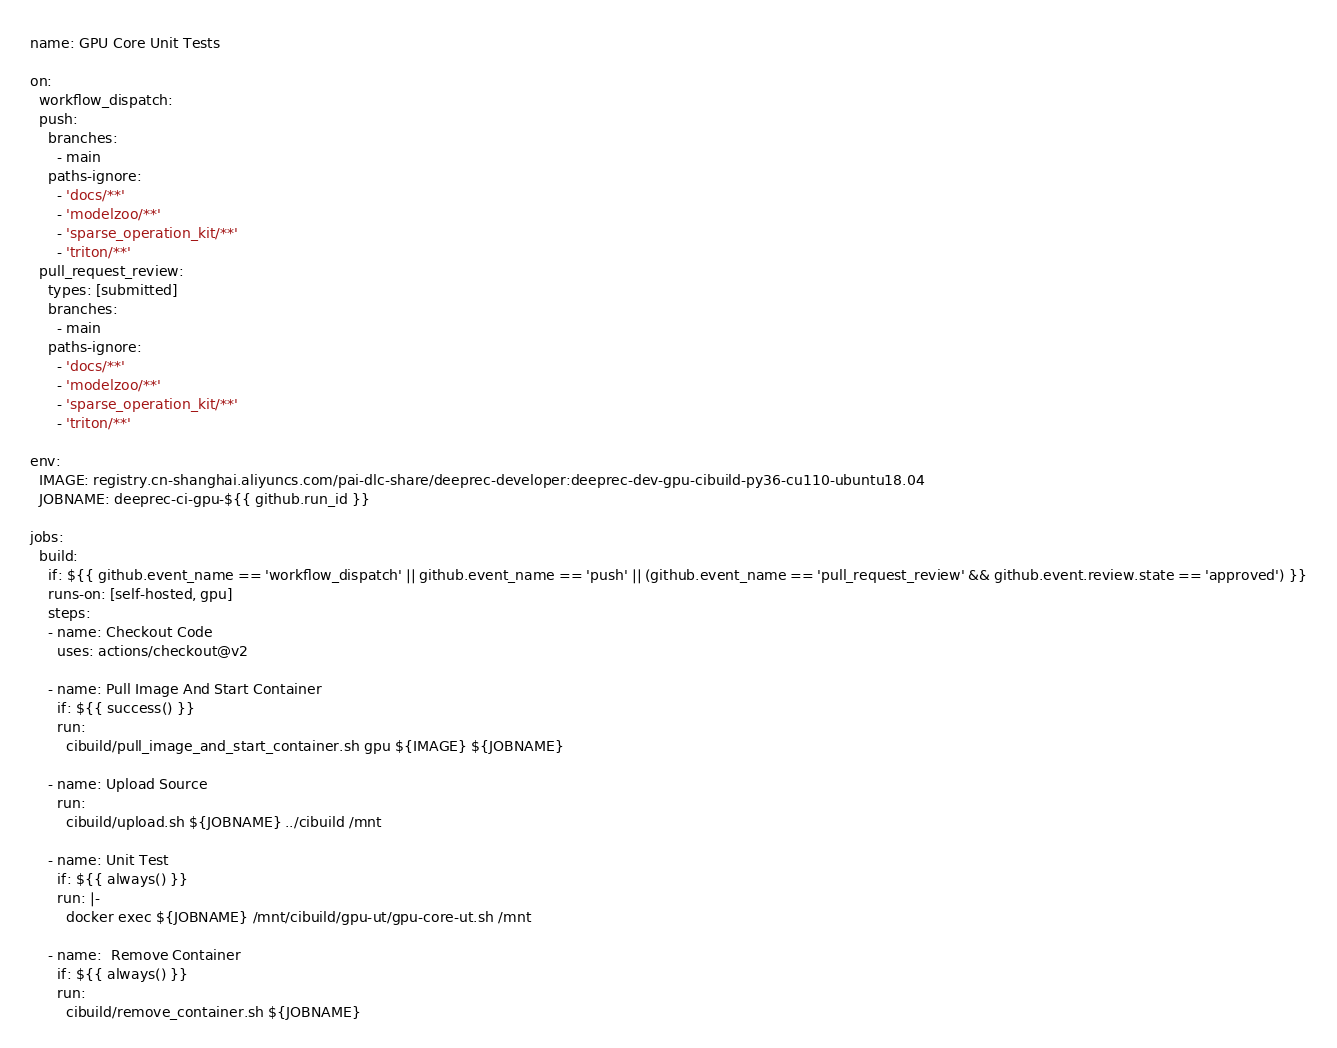<code> <loc_0><loc_0><loc_500><loc_500><_YAML_>name: GPU Core Unit Tests

on: 
  workflow_dispatch:
  push:
    branches:
      - main
    paths-ignore:
      - 'docs/**'
      - 'modelzoo/**'
      - 'sparse_operation_kit/**'
      - 'triton/**'
  pull_request_review:
    types: [submitted]
    branches:
      - main
    paths-ignore:
      - 'docs/**'
      - 'modelzoo/**'
      - 'sparse_operation_kit/**'
      - 'triton/**'

env:
  IMAGE: registry.cn-shanghai.aliyuncs.com/pai-dlc-share/deeprec-developer:deeprec-dev-gpu-cibuild-py36-cu110-ubuntu18.04
  JOBNAME: deeprec-ci-gpu-${{ github.run_id }}

jobs:
  build:
    if: ${{ github.event_name == 'workflow_dispatch' || github.event_name == 'push' || (github.event_name == 'pull_request_review' && github.event.review.state == 'approved') }}
    runs-on: [self-hosted, gpu]
    steps:
    - name: Checkout Code
      uses: actions/checkout@v2
    
    - name: Pull Image And Start Container
      if: ${{ success() }}
      run:
        cibuild/pull_image_and_start_container.sh gpu ${IMAGE} ${JOBNAME}

    - name: Upload Source
      run:
        cibuild/upload.sh ${JOBNAME} ../cibuild /mnt

    - name: Unit Test
      if: ${{ always() }}
      run: |-
        docker exec ${JOBNAME} /mnt/cibuild/gpu-ut/gpu-core-ut.sh /mnt
    
    - name:  Remove Container
      if: ${{ always() }}
      run: 
        cibuild/remove_container.sh ${JOBNAME}</code> 